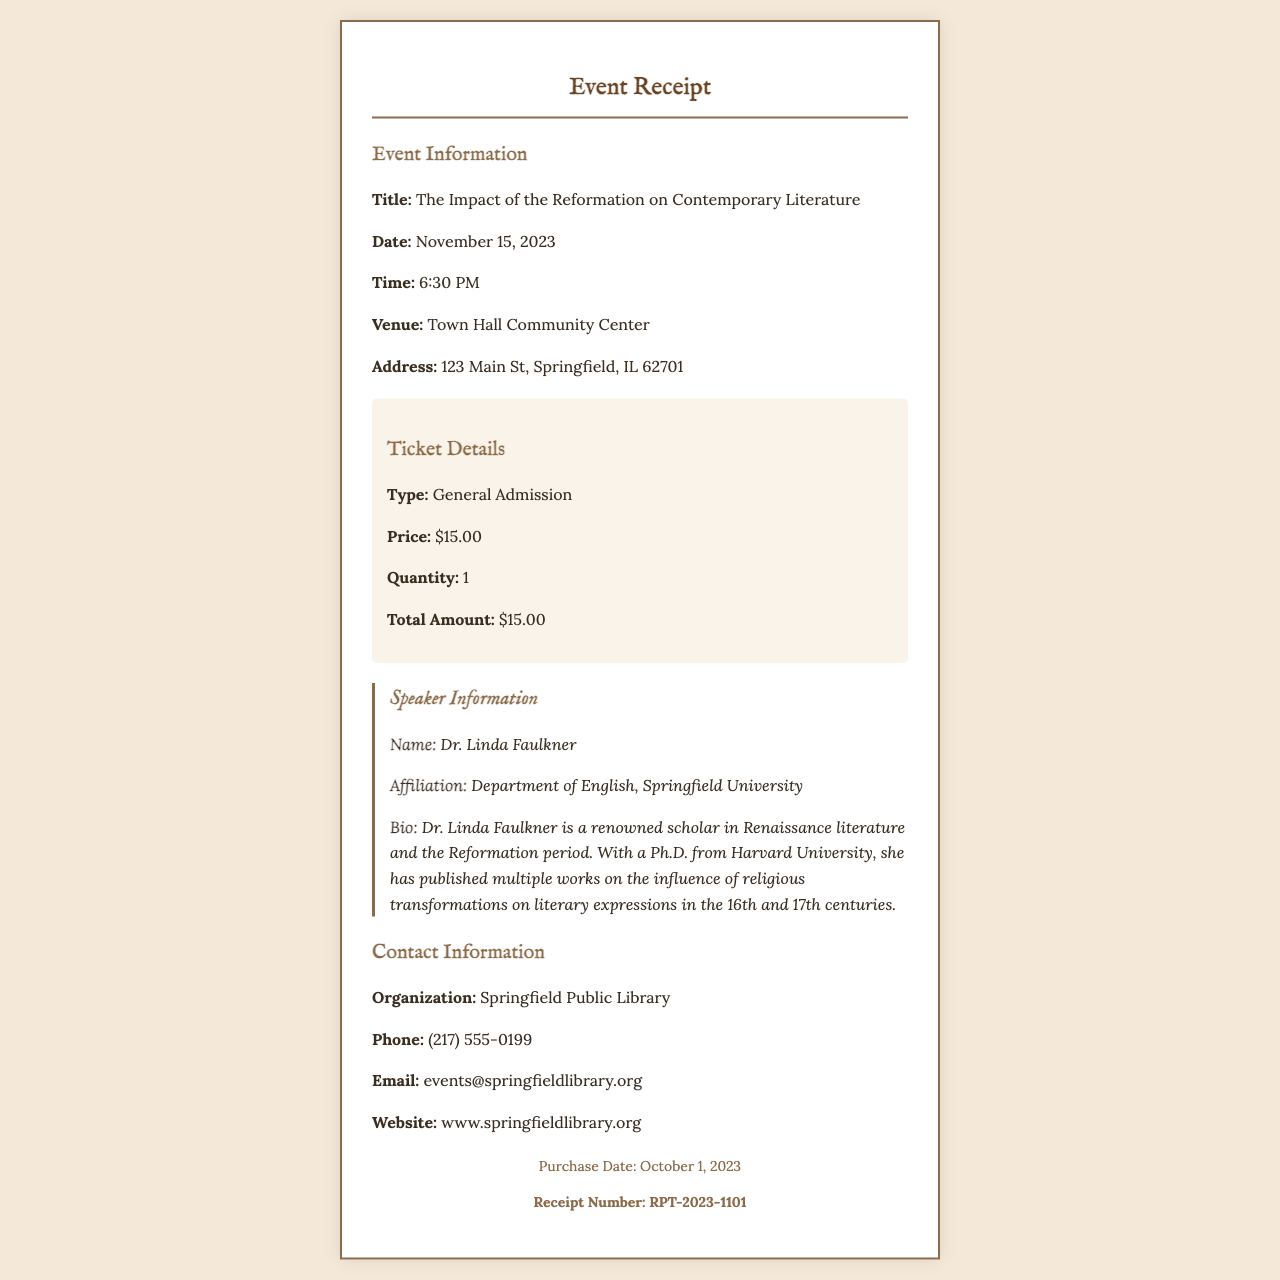What is the title of the event? The title of the event is explicitly stated in the document under Event Information.
Answer: The Impact of the Reformation on Contemporary Literature What is the date of the event? The date of the event is clearly mentioned in the document under Event Information.
Answer: November 15, 2023 Who is the speaker? The speaker's name is provided in the Speaker Information section of the document.
Answer: Dr. Linda Faulkner What is the price of the ticket? The price of the ticket is listed in the Ticket Details section of the document.
Answer: $15.00 What is the quantity of tickets purchased? The quantity of tickets is stated in the Ticket Details section of the document.
Answer: 1 What organization is hosting the event? The hosting organization is mentioned in the Contact Information section of the document.
Answer: Springfield Public Library What is the receipt number? The receipt number is specified in the footer of the document.
Answer: RPT-2023-1101 What is the venue for the event? The venue is detailed in the Event Information section of the document.
Answer: Town Hall Community Center Who is affiliated with Springfield University? The affiliation of the speaker is found in the Speaker Information section.
Answer: Dr. Linda Faulkner 